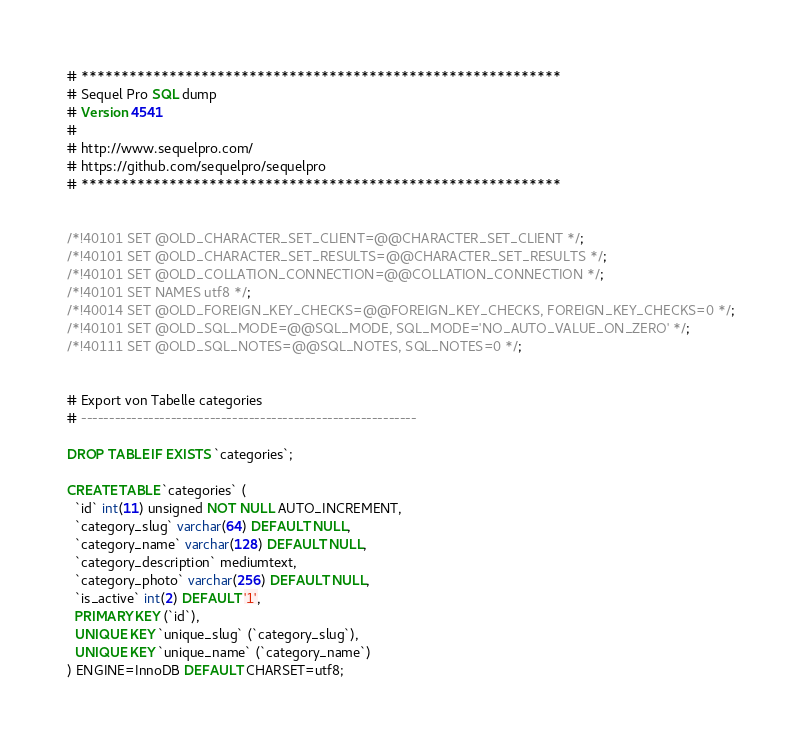Convert code to text. <code><loc_0><loc_0><loc_500><loc_500><_SQL_># ************************************************************
# Sequel Pro SQL dump
# Version 4541
#
# http://www.sequelpro.com/
# https://github.com/sequelpro/sequelpro
# ************************************************************


/*!40101 SET @OLD_CHARACTER_SET_CLIENT=@@CHARACTER_SET_CLIENT */;
/*!40101 SET @OLD_CHARACTER_SET_RESULTS=@@CHARACTER_SET_RESULTS */;
/*!40101 SET @OLD_COLLATION_CONNECTION=@@COLLATION_CONNECTION */;
/*!40101 SET NAMES utf8 */;
/*!40014 SET @OLD_FOREIGN_KEY_CHECKS=@@FOREIGN_KEY_CHECKS, FOREIGN_KEY_CHECKS=0 */;
/*!40101 SET @OLD_SQL_MODE=@@SQL_MODE, SQL_MODE='NO_AUTO_VALUE_ON_ZERO' */;
/*!40111 SET @OLD_SQL_NOTES=@@SQL_NOTES, SQL_NOTES=0 */;


# Export von Tabelle categories
# ------------------------------------------------------------

DROP TABLE IF EXISTS `categories`;

CREATE TABLE `categories` (
  `id` int(11) unsigned NOT NULL AUTO_INCREMENT,
  `category_slug` varchar(64) DEFAULT NULL,
  `category_name` varchar(128) DEFAULT NULL,
  `category_description` mediumtext,
  `category_photo` varchar(256) DEFAULT NULL,
  `is_active` int(2) DEFAULT '1',
  PRIMARY KEY (`id`),
  UNIQUE KEY `unique_slug` (`category_slug`),
  UNIQUE KEY `unique_name` (`category_name`)
) ENGINE=InnoDB DEFAULT CHARSET=utf8;
</code> 